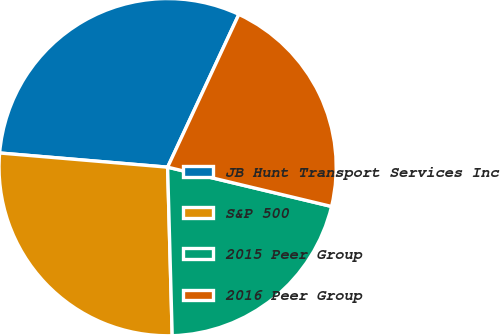Convert chart. <chart><loc_0><loc_0><loc_500><loc_500><pie_chart><fcel>JB Hunt Transport Services Inc<fcel>S&P 500<fcel>2015 Peer Group<fcel>2016 Peer Group<nl><fcel>30.6%<fcel>26.77%<fcel>20.82%<fcel>21.8%<nl></chart> 